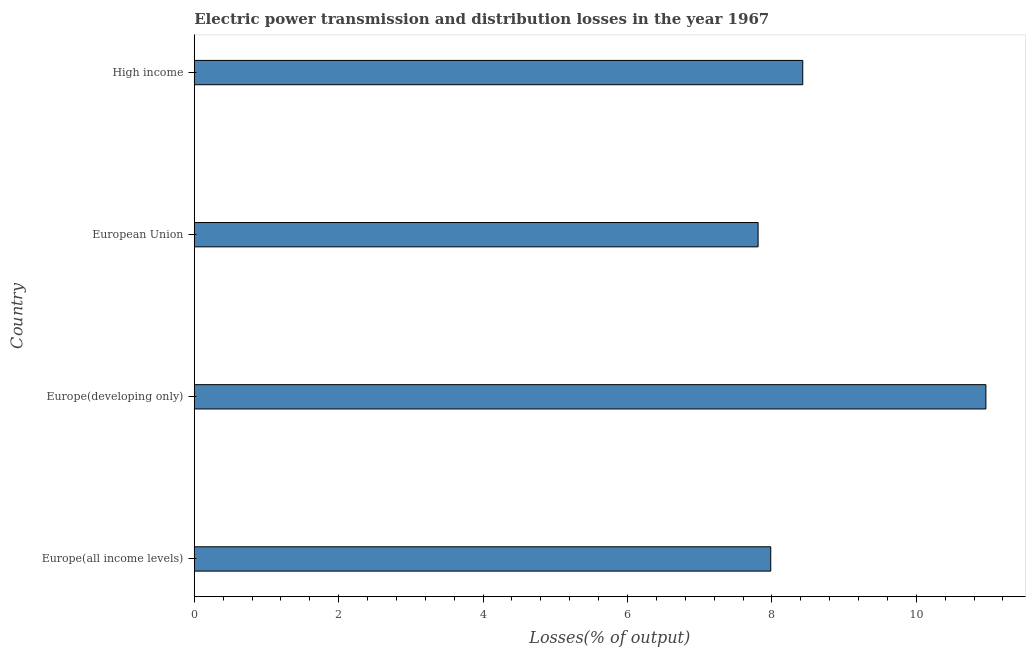Does the graph contain any zero values?
Provide a short and direct response. No. Does the graph contain grids?
Offer a very short reply. No. What is the title of the graph?
Your response must be concise. Electric power transmission and distribution losses in the year 1967. What is the label or title of the X-axis?
Provide a succinct answer. Losses(% of output). What is the label or title of the Y-axis?
Give a very brief answer. Country. What is the electric power transmission and distribution losses in Europe(developing only)?
Your response must be concise. 10.96. Across all countries, what is the maximum electric power transmission and distribution losses?
Ensure brevity in your answer.  10.96. Across all countries, what is the minimum electric power transmission and distribution losses?
Give a very brief answer. 7.81. In which country was the electric power transmission and distribution losses maximum?
Your answer should be very brief. Europe(developing only). What is the sum of the electric power transmission and distribution losses?
Provide a short and direct response. 35.19. What is the difference between the electric power transmission and distribution losses in European Union and High income?
Your answer should be very brief. -0.62. What is the average electric power transmission and distribution losses per country?
Offer a terse response. 8.8. What is the median electric power transmission and distribution losses?
Offer a terse response. 8.21. What is the ratio of the electric power transmission and distribution losses in Europe(developing only) to that in High income?
Your answer should be very brief. 1.3. Is the electric power transmission and distribution losses in Europe(all income levels) less than that in High income?
Provide a short and direct response. Yes. Is the difference between the electric power transmission and distribution losses in Europe(all income levels) and Europe(developing only) greater than the difference between any two countries?
Make the answer very short. No. What is the difference between the highest and the second highest electric power transmission and distribution losses?
Make the answer very short. 2.54. What is the difference between the highest and the lowest electric power transmission and distribution losses?
Provide a short and direct response. 3.16. Are all the bars in the graph horizontal?
Give a very brief answer. Yes. How many countries are there in the graph?
Make the answer very short. 4. What is the difference between two consecutive major ticks on the X-axis?
Offer a terse response. 2. What is the Losses(% of output) in Europe(all income levels)?
Give a very brief answer. 7.98. What is the Losses(% of output) of Europe(developing only)?
Keep it short and to the point. 10.96. What is the Losses(% of output) of European Union?
Provide a succinct answer. 7.81. What is the Losses(% of output) in High income?
Give a very brief answer. 8.43. What is the difference between the Losses(% of output) in Europe(all income levels) and Europe(developing only)?
Ensure brevity in your answer.  -2.98. What is the difference between the Losses(% of output) in Europe(all income levels) and European Union?
Your answer should be compact. 0.18. What is the difference between the Losses(% of output) in Europe(all income levels) and High income?
Provide a short and direct response. -0.44. What is the difference between the Losses(% of output) in Europe(developing only) and European Union?
Offer a very short reply. 3.16. What is the difference between the Losses(% of output) in Europe(developing only) and High income?
Ensure brevity in your answer.  2.54. What is the difference between the Losses(% of output) in European Union and High income?
Give a very brief answer. -0.62. What is the ratio of the Losses(% of output) in Europe(all income levels) to that in Europe(developing only)?
Offer a very short reply. 0.73. What is the ratio of the Losses(% of output) in Europe(all income levels) to that in European Union?
Offer a terse response. 1.02. What is the ratio of the Losses(% of output) in Europe(all income levels) to that in High income?
Give a very brief answer. 0.95. What is the ratio of the Losses(% of output) in Europe(developing only) to that in European Union?
Provide a succinct answer. 1.4. What is the ratio of the Losses(% of output) in Europe(developing only) to that in High income?
Provide a succinct answer. 1.3. What is the ratio of the Losses(% of output) in European Union to that in High income?
Make the answer very short. 0.93. 